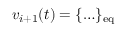Convert formula to latex. <formula><loc_0><loc_0><loc_500><loc_500>v _ { i + 1 } ( t ) = \{ \dots \} _ { e q }</formula> 